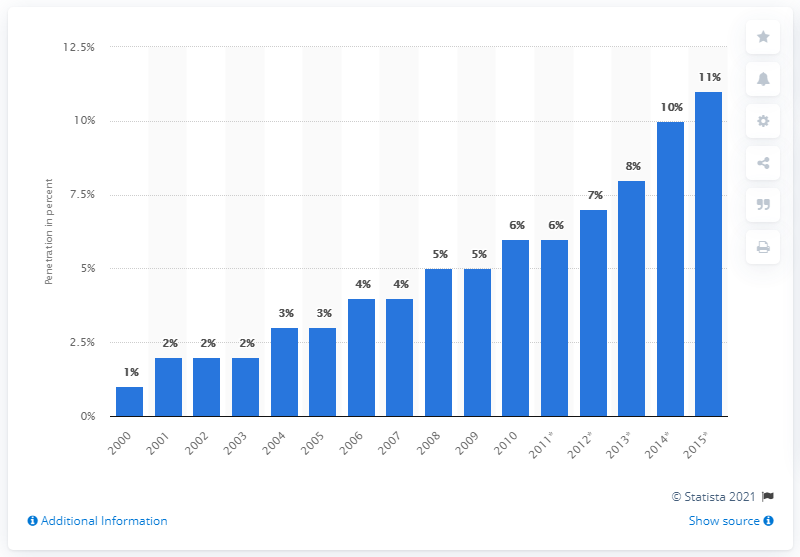Draw attention to some important aspects in this diagram. According to projections, the per capita PC penetration in 2015 was expected to be 11. 